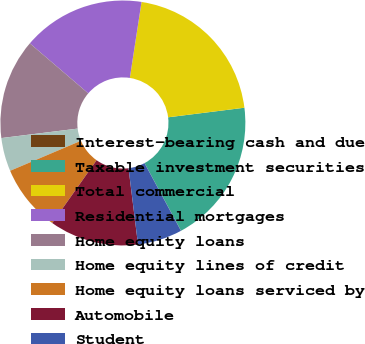<chart> <loc_0><loc_0><loc_500><loc_500><pie_chart><fcel>Interest-bearing cash and due<fcel>Taxable investment securities<fcel>Total commercial<fcel>Residential mortgages<fcel>Home equity loans<fcel>Home equity lines of credit<fcel>Home equity loans serviced by<fcel>Automobile<fcel>Student<nl><fcel>0.02%<fcel>19.11%<fcel>20.58%<fcel>16.17%<fcel>13.23%<fcel>4.42%<fcel>8.83%<fcel>11.76%<fcel>5.89%<nl></chart> 